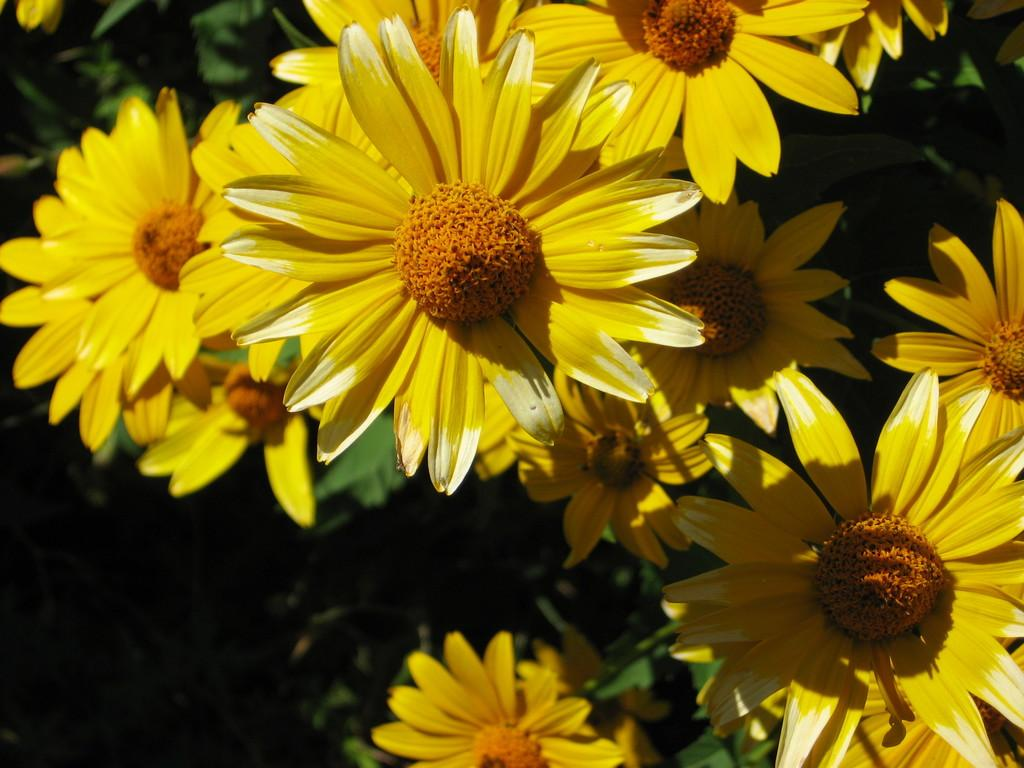What type of plants are featured in the image? The image features plants with flowers that have yellow petals. What other parts of the plants can be seen in the image? Leaves are also visible in the image. What is the color of the flowers' petals? The flowers have yellow petals. What is the background of the image like? The backdrop of the image is dark. Can you tell me how many cushions are in the image? There are no cushions present in the image. What type of friction can be observed between the flowers and the leaves in the image? There is no friction between the flowers and the leaves in the image; they are simply attached to the plants. 